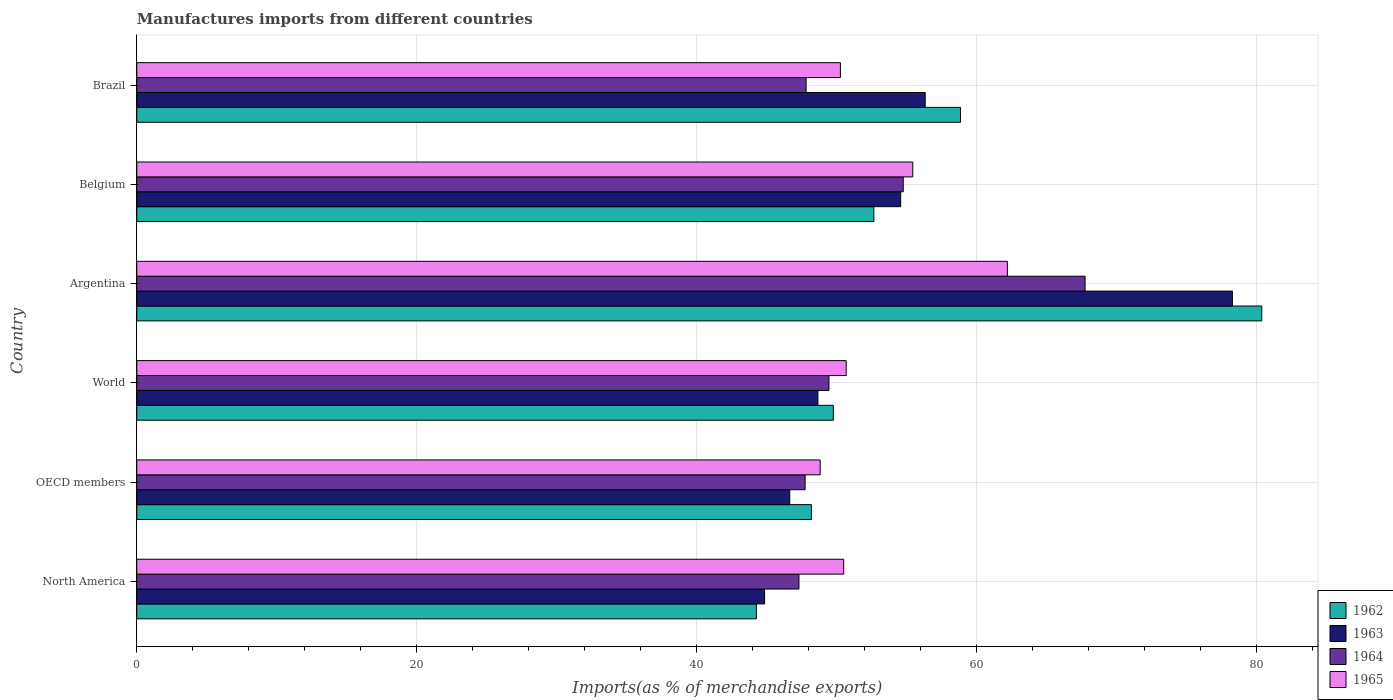How many different coloured bars are there?
Ensure brevity in your answer.  4. How many groups of bars are there?
Give a very brief answer. 6. How many bars are there on the 4th tick from the top?
Your answer should be compact. 4. In how many cases, is the number of bars for a given country not equal to the number of legend labels?
Make the answer very short. 0. What is the percentage of imports to different countries in 1965 in OECD members?
Your response must be concise. 48.82. Across all countries, what is the maximum percentage of imports to different countries in 1962?
Offer a very short reply. 80.37. Across all countries, what is the minimum percentage of imports to different countries in 1965?
Offer a very short reply. 48.82. In which country was the percentage of imports to different countries in 1962 maximum?
Ensure brevity in your answer.  Argentina. In which country was the percentage of imports to different countries in 1963 minimum?
Your answer should be very brief. North America. What is the total percentage of imports to different countries in 1964 in the graph?
Offer a terse response. 314.81. What is the difference between the percentage of imports to different countries in 1962 in Belgium and that in OECD members?
Your answer should be compact. 4.46. What is the difference between the percentage of imports to different countries in 1962 in World and the percentage of imports to different countries in 1965 in North America?
Keep it short and to the point. -0.74. What is the average percentage of imports to different countries in 1965 per country?
Your answer should be very brief. 52.98. What is the difference between the percentage of imports to different countries in 1964 and percentage of imports to different countries in 1965 in Argentina?
Your response must be concise. 5.55. What is the ratio of the percentage of imports to different countries in 1965 in OECD members to that in World?
Keep it short and to the point. 0.96. Is the difference between the percentage of imports to different countries in 1964 in Brazil and World greater than the difference between the percentage of imports to different countries in 1965 in Brazil and World?
Offer a terse response. No. What is the difference between the highest and the second highest percentage of imports to different countries in 1964?
Provide a succinct answer. 12.99. What is the difference between the highest and the lowest percentage of imports to different countries in 1962?
Offer a terse response. 36.1. Is it the case that in every country, the sum of the percentage of imports to different countries in 1962 and percentage of imports to different countries in 1965 is greater than the sum of percentage of imports to different countries in 1963 and percentage of imports to different countries in 1964?
Make the answer very short. No. What does the 2nd bar from the bottom in OECD members represents?
Your response must be concise. 1963. How many bars are there?
Provide a short and direct response. 24. How many countries are there in the graph?
Your answer should be compact. 6. Does the graph contain any zero values?
Keep it short and to the point. No. How many legend labels are there?
Give a very brief answer. 4. What is the title of the graph?
Your response must be concise. Manufactures imports from different countries. What is the label or title of the X-axis?
Give a very brief answer. Imports(as % of merchandise exports). What is the Imports(as % of merchandise exports) of 1962 in North America?
Offer a terse response. 44.26. What is the Imports(as % of merchandise exports) of 1963 in North America?
Your answer should be very brief. 44.85. What is the Imports(as % of merchandise exports) of 1964 in North America?
Your answer should be very brief. 47.3. What is the Imports(as % of merchandise exports) in 1965 in North America?
Make the answer very short. 50.5. What is the Imports(as % of merchandise exports) of 1962 in OECD members?
Your answer should be very brief. 48.19. What is the Imports(as % of merchandise exports) in 1963 in OECD members?
Provide a short and direct response. 46.65. What is the Imports(as % of merchandise exports) of 1964 in OECD members?
Make the answer very short. 47.75. What is the Imports(as % of merchandise exports) in 1965 in OECD members?
Offer a very short reply. 48.82. What is the Imports(as % of merchandise exports) in 1962 in World?
Offer a terse response. 49.76. What is the Imports(as % of merchandise exports) of 1963 in World?
Make the answer very short. 48.66. What is the Imports(as % of merchandise exports) in 1964 in World?
Your answer should be very brief. 49.45. What is the Imports(as % of merchandise exports) in 1965 in World?
Ensure brevity in your answer.  50.68. What is the Imports(as % of merchandise exports) of 1962 in Argentina?
Your response must be concise. 80.37. What is the Imports(as % of merchandise exports) in 1963 in Argentina?
Provide a succinct answer. 78.27. What is the Imports(as % of merchandise exports) in 1964 in Argentina?
Offer a very short reply. 67.75. What is the Imports(as % of merchandise exports) of 1965 in Argentina?
Your response must be concise. 62.19. What is the Imports(as % of merchandise exports) of 1962 in Belgium?
Ensure brevity in your answer.  52.65. What is the Imports(as % of merchandise exports) of 1963 in Belgium?
Make the answer very short. 54.57. What is the Imports(as % of merchandise exports) of 1964 in Belgium?
Your response must be concise. 54.75. What is the Imports(as % of merchandise exports) of 1965 in Belgium?
Provide a short and direct response. 55.44. What is the Imports(as % of merchandise exports) of 1962 in Brazil?
Keep it short and to the point. 58.85. What is the Imports(as % of merchandise exports) in 1963 in Brazil?
Your response must be concise. 56.32. What is the Imports(as % of merchandise exports) of 1964 in Brazil?
Make the answer very short. 47.82. What is the Imports(as % of merchandise exports) in 1965 in Brazil?
Ensure brevity in your answer.  50.27. Across all countries, what is the maximum Imports(as % of merchandise exports) of 1962?
Your answer should be compact. 80.37. Across all countries, what is the maximum Imports(as % of merchandise exports) in 1963?
Provide a short and direct response. 78.27. Across all countries, what is the maximum Imports(as % of merchandise exports) in 1964?
Your answer should be compact. 67.75. Across all countries, what is the maximum Imports(as % of merchandise exports) of 1965?
Your answer should be compact. 62.19. Across all countries, what is the minimum Imports(as % of merchandise exports) of 1962?
Your answer should be compact. 44.26. Across all countries, what is the minimum Imports(as % of merchandise exports) of 1963?
Provide a short and direct response. 44.85. Across all countries, what is the minimum Imports(as % of merchandise exports) in 1964?
Give a very brief answer. 47.3. Across all countries, what is the minimum Imports(as % of merchandise exports) in 1965?
Your answer should be very brief. 48.82. What is the total Imports(as % of merchandise exports) in 1962 in the graph?
Your answer should be very brief. 334.08. What is the total Imports(as % of merchandise exports) in 1963 in the graph?
Offer a terse response. 329.32. What is the total Imports(as % of merchandise exports) in 1964 in the graph?
Keep it short and to the point. 314.81. What is the total Imports(as % of merchandise exports) of 1965 in the graph?
Ensure brevity in your answer.  317.9. What is the difference between the Imports(as % of merchandise exports) of 1962 in North America and that in OECD members?
Ensure brevity in your answer.  -3.93. What is the difference between the Imports(as % of merchandise exports) of 1963 in North America and that in OECD members?
Ensure brevity in your answer.  -1.8. What is the difference between the Imports(as % of merchandise exports) of 1964 in North America and that in OECD members?
Your answer should be compact. -0.44. What is the difference between the Imports(as % of merchandise exports) of 1965 in North America and that in OECD members?
Make the answer very short. 1.68. What is the difference between the Imports(as % of merchandise exports) of 1962 in North America and that in World?
Provide a short and direct response. -5.5. What is the difference between the Imports(as % of merchandise exports) of 1963 in North America and that in World?
Give a very brief answer. -3.81. What is the difference between the Imports(as % of merchandise exports) of 1964 in North America and that in World?
Provide a succinct answer. -2.14. What is the difference between the Imports(as % of merchandise exports) of 1965 in North America and that in World?
Offer a very short reply. -0.18. What is the difference between the Imports(as % of merchandise exports) of 1962 in North America and that in Argentina?
Provide a short and direct response. -36.1. What is the difference between the Imports(as % of merchandise exports) in 1963 in North America and that in Argentina?
Ensure brevity in your answer.  -33.42. What is the difference between the Imports(as % of merchandise exports) of 1964 in North America and that in Argentina?
Ensure brevity in your answer.  -20.44. What is the difference between the Imports(as % of merchandise exports) of 1965 in North America and that in Argentina?
Offer a terse response. -11.69. What is the difference between the Imports(as % of merchandise exports) in 1962 in North America and that in Belgium?
Give a very brief answer. -8.39. What is the difference between the Imports(as % of merchandise exports) in 1963 in North America and that in Belgium?
Your answer should be very brief. -9.72. What is the difference between the Imports(as % of merchandise exports) of 1964 in North America and that in Belgium?
Provide a succinct answer. -7.45. What is the difference between the Imports(as % of merchandise exports) of 1965 in North America and that in Belgium?
Offer a very short reply. -4.93. What is the difference between the Imports(as % of merchandise exports) in 1962 in North America and that in Brazil?
Provide a short and direct response. -14.58. What is the difference between the Imports(as % of merchandise exports) of 1963 in North America and that in Brazil?
Ensure brevity in your answer.  -11.47. What is the difference between the Imports(as % of merchandise exports) in 1964 in North America and that in Brazil?
Offer a very short reply. -0.51. What is the difference between the Imports(as % of merchandise exports) in 1965 in North America and that in Brazil?
Your answer should be very brief. 0.24. What is the difference between the Imports(as % of merchandise exports) of 1962 in OECD members and that in World?
Provide a succinct answer. -1.57. What is the difference between the Imports(as % of merchandise exports) of 1963 in OECD members and that in World?
Offer a very short reply. -2.01. What is the difference between the Imports(as % of merchandise exports) in 1964 in OECD members and that in World?
Offer a terse response. -1.7. What is the difference between the Imports(as % of merchandise exports) of 1965 in OECD members and that in World?
Make the answer very short. -1.86. What is the difference between the Imports(as % of merchandise exports) of 1962 in OECD members and that in Argentina?
Ensure brevity in your answer.  -32.17. What is the difference between the Imports(as % of merchandise exports) in 1963 in OECD members and that in Argentina?
Your response must be concise. -31.62. What is the difference between the Imports(as % of merchandise exports) of 1964 in OECD members and that in Argentina?
Provide a short and direct response. -20. What is the difference between the Imports(as % of merchandise exports) of 1965 in OECD members and that in Argentina?
Keep it short and to the point. -13.38. What is the difference between the Imports(as % of merchandise exports) in 1962 in OECD members and that in Belgium?
Provide a short and direct response. -4.46. What is the difference between the Imports(as % of merchandise exports) of 1963 in OECD members and that in Belgium?
Offer a very short reply. -7.93. What is the difference between the Imports(as % of merchandise exports) of 1964 in OECD members and that in Belgium?
Provide a succinct answer. -7.01. What is the difference between the Imports(as % of merchandise exports) in 1965 in OECD members and that in Belgium?
Make the answer very short. -6.62. What is the difference between the Imports(as % of merchandise exports) of 1962 in OECD members and that in Brazil?
Your answer should be compact. -10.66. What is the difference between the Imports(as % of merchandise exports) of 1963 in OECD members and that in Brazil?
Offer a terse response. -9.68. What is the difference between the Imports(as % of merchandise exports) of 1964 in OECD members and that in Brazil?
Provide a succinct answer. -0.07. What is the difference between the Imports(as % of merchandise exports) in 1965 in OECD members and that in Brazil?
Give a very brief answer. -1.45. What is the difference between the Imports(as % of merchandise exports) in 1962 in World and that in Argentina?
Provide a short and direct response. -30.61. What is the difference between the Imports(as % of merchandise exports) of 1963 in World and that in Argentina?
Provide a short and direct response. -29.61. What is the difference between the Imports(as % of merchandise exports) in 1964 in World and that in Argentina?
Your response must be concise. -18.3. What is the difference between the Imports(as % of merchandise exports) in 1965 in World and that in Argentina?
Provide a succinct answer. -11.52. What is the difference between the Imports(as % of merchandise exports) of 1962 in World and that in Belgium?
Offer a terse response. -2.89. What is the difference between the Imports(as % of merchandise exports) of 1963 in World and that in Belgium?
Your answer should be compact. -5.91. What is the difference between the Imports(as % of merchandise exports) of 1964 in World and that in Belgium?
Keep it short and to the point. -5.31. What is the difference between the Imports(as % of merchandise exports) in 1965 in World and that in Belgium?
Offer a terse response. -4.76. What is the difference between the Imports(as % of merchandise exports) of 1962 in World and that in Brazil?
Your answer should be compact. -9.09. What is the difference between the Imports(as % of merchandise exports) of 1963 in World and that in Brazil?
Your answer should be compact. -7.66. What is the difference between the Imports(as % of merchandise exports) in 1964 in World and that in Brazil?
Make the answer very short. 1.63. What is the difference between the Imports(as % of merchandise exports) of 1965 in World and that in Brazil?
Make the answer very short. 0.41. What is the difference between the Imports(as % of merchandise exports) of 1962 in Argentina and that in Belgium?
Your answer should be compact. 27.71. What is the difference between the Imports(as % of merchandise exports) in 1963 in Argentina and that in Belgium?
Make the answer very short. 23.7. What is the difference between the Imports(as % of merchandise exports) in 1964 in Argentina and that in Belgium?
Your answer should be very brief. 12.99. What is the difference between the Imports(as % of merchandise exports) in 1965 in Argentina and that in Belgium?
Offer a very short reply. 6.76. What is the difference between the Imports(as % of merchandise exports) in 1962 in Argentina and that in Brazil?
Keep it short and to the point. 21.52. What is the difference between the Imports(as % of merchandise exports) in 1963 in Argentina and that in Brazil?
Offer a very short reply. 21.95. What is the difference between the Imports(as % of merchandise exports) in 1964 in Argentina and that in Brazil?
Your answer should be very brief. 19.93. What is the difference between the Imports(as % of merchandise exports) in 1965 in Argentina and that in Brazil?
Keep it short and to the point. 11.93. What is the difference between the Imports(as % of merchandise exports) in 1962 in Belgium and that in Brazil?
Give a very brief answer. -6.19. What is the difference between the Imports(as % of merchandise exports) in 1963 in Belgium and that in Brazil?
Give a very brief answer. -1.75. What is the difference between the Imports(as % of merchandise exports) in 1964 in Belgium and that in Brazil?
Your answer should be compact. 6.94. What is the difference between the Imports(as % of merchandise exports) of 1965 in Belgium and that in Brazil?
Offer a very short reply. 5.17. What is the difference between the Imports(as % of merchandise exports) of 1962 in North America and the Imports(as % of merchandise exports) of 1963 in OECD members?
Ensure brevity in your answer.  -2.38. What is the difference between the Imports(as % of merchandise exports) in 1962 in North America and the Imports(as % of merchandise exports) in 1964 in OECD members?
Offer a terse response. -3.48. What is the difference between the Imports(as % of merchandise exports) in 1962 in North America and the Imports(as % of merchandise exports) in 1965 in OECD members?
Provide a succinct answer. -4.56. What is the difference between the Imports(as % of merchandise exports) in 1963 in North America and the Imports(as % of merchandise exports) in 1964 in OECD members?
Provide a succinct answer. -2.89. What is the difference between the Imports(as % of merchandise exports) in 1963 in North America and the Imports(as % of merchandise exports) in 1965 in OECD members?
Your answer should be compact. -3.97. What is the difference between the Imports(as % of merchandise exports) of 1964 in North America and the Imports(as % of merchandise exports) of 1965 in OECD members?
Offer a terse response. -1.52. What is the difference between the Imports(as % of merchandise exports) in 1962 in North America and the Imports(as % of merchandise exports) in 1963 in World?
Give a very brief answer. -4.4. What is the difference between the Imports(as % of merchandise exports) in 1962 in North America and the Imports(as % of merchandise exports) in 1964 in World?
Ensure brevity in your answer.  -5.19. What is the difference between the Imports(as % of merchandise exports) in 1962 in North America and the Imports(as % of merchandise exports) in 1965 in World?
Offer a terse response. -6.42. What is the difference between the Imports(as % of merchandise exports) in 1963 in North America and the Imports(as % of merchandise exports) in 1964 in World?
Offer a very short reply. -4.6. What is the difference between the Imports(as % of merchandise exports) in 1963 in North America and the Imports(as % of merchandise exports) in 1965 in World?
Offer a terse response. -5.83. What is the difference between the Imports(as % of merchandise exports) of 1964 in North America and the Imports(as % of merchandise exports) of 1965 in World?
Keep it short and to the point. -3.37. What is the difference between the Imports(as % of merchandise exports) of 1962 in North America and the Imports(as % of merchandise exports) of 1963 in Argentina?
Offer a very short reply. -34.01. What is the difference between the Imports(as % of merchandise exports) in 1962 in North America and the Imports(as % of merchandise exports) in 1964 in Argentina?
Provide a succinct answer. -23.48. What is the difference between the Imports(as % of merchandise exports) of 1962 in North America and the Imports(as % of merchandise exports) of 1965 in Argentina?
Keep it short and to the point. -17.93. What is the difference between the Imports(as % of merchandise exports) of 1963 in North America and the Imports(as % of merchandise exports) of 1964 in Argentina?
Offer a very short reply. -22.89. What is the difference between the Imports(as % of merchandise exports) in 1963 in North America and the Imports(as % of merchandise exports) in 1965 in Argentina?
Offer a very short reply. -17.34. What is the difference between the Imports(as % of merchandise exports) in 1964 in North America and the Imports(as % of merchandise exports) in 1965 in Argentina?
Your answer should be very brief. -14.89. What is the difference between the Imports(as % of merchandise exports) in 1962 in North America and the Imports(as % of merchandise exports) in 1963 in Belgium?
Provide a succinct answer. -10.31. What is the difference between the Imports(as % of merchandise exports) in 1962 in North America and the Imports(as % of merchandise exports) in 1964 in Belgium?
Offer a terse response. -10.49. What is the difference between the Imports(as % of merchandise exports) of 1962 in North America and the Imports(as % of merchandise exports) of 1965 in Belgium?
Provide a short and direct response. -11.17. What is the difference between the Imports(as % of merchandise exports) in 1963 in North America and the Imports(as % of merchandise exports) in 1964 in Belgium?
Give a very brief answer. -9.9. What is the difference between the Imports(as % of merchandise exports) of 1963 in North America and the Imports(as % of merchandise exports) of 1965 in Belgium?
Your answer should be very brief. -10.58. What is the difference between the Imports(as % of merchandise exports) in 1964 in North America and the Imports(as % of merchandise exports) in 1965 in Belgium?
Ensure brevity in your answer.  -8.13. What is the difference between the Imports(as % of merchandise exports) in 1962 in North America and the Imports(as % of merchandise exports) in 1963 in Brazil?
Make the answer very short. -12.06. What is the difference between the Imports(as % of merchandise exports) in 1962 in North America and the Imports(as % of merchandise exports) in 1964 in Brazil?
Your answer should be compact. -3.55. What is the difference between the Imports(as % of merchandise exports) of 1962 in North America and the Imports(as % of merchandise exports) of 1965 in Brazil?
Your answer should be compact. -6. What is the difference between the Imports(as % of merchandise exports) in 1963 in North America and the Imports(as % of merchandise exports) in 1964 in Brazil?
Offer a very short reply. -2.96. What is the difference between the Imports(as % of merchandise exports) in 1963 in North America and the Imports(as % of merchandise exports) in 1965 in Brazil?
Give a very brief answer. -5.42. What is the difference between the Imports(as % of merchandise exports) of 1964 in North America and the Imports(as % of merchandise exports) of 1965 in Brazil?
Give a very brief answer. -2.96. What is the difference between the Imports(as % of merchandise exports) of 1962 in OECD members and the Imports(as % of merchandise exports) of 1963 in World?
Ensure brevity in your answer.  -0.47. What is the difference between the Imports(as % of merchandise exports) of 1962 in OECD members and the Imports(as % of merchandise exports) of 1964 in World?
Your response must be concise. -1.26. What is the difference between the Imports(as % of merchandise exports) in 1962 in OECD members and the Imports(as % of merchandise exports) in 1965 in World?
Ensure brevity in your answer.  -2.49. What is the difference between the Imports(as % of merchandise exports) in 1963 in OECD members and the Imports(as % of merchandise exports) in 1964 in World?
Your response must be concise. -2.8. What is the difference between the Imports(as % of merchandise exports) of 1963 in OECD members and the Imports(as % of merchandise exports) of 1965 in World?
Your answer should be very brief. -4.03. What is the difference between the Imports(as % of merchandise exports) in 1964 in OECD members and the Imports(as % of merchandise exports) in 1965 in World?
Offer a terse response. -2.93. What is the difference between the Imports(as % of merchandise exports) of 1962 in OECD members and the Imports(as % of merchandise exports) of 1963 in Argentina?
Make the answer very short. -30.08. What is the difference between the Imports(as % of merchandise exports) of 1962 in OECD members and the Imports(as % of merchandise exports) of 1964 in Argentina?
Your answer should be very brief. -19.55. What is the difference between the Imports(as % of merchandise exports) in 1962 in OECD members and the Imports(as % of merchandise exports) in 1965 in Argentina?
Ensure brevity in your answer.  -14. What is the difference between the Imports(as % of merchandise exports) of 1963 in OECD members and the Imports(as % of merchandise exports) of 1964 in Argentina?
Ensure brevity in your answer.  -21.1. What is the difference between the Imports(as % of merchandise exports) in 1963 in OECD members and the Imports(as % of merchandise exports) in 1965 in Argentina?
Your answer should be compact. -15.55. What is the difference between the Imports(as % of merchandise exports) of 1964 in OECD members and the Imports(as % of merchandise exports) of 1965 in Argentina?
Ensure brevity in your answer.  -14.45. What is the difference between the Imports(as % of merchandise exports) of 1962 in OECD members and the Imports(as % of merchandise exports) of 1963 in Belgium?
Provide a succinct answer. -6.38. What is the difference between the Imports(as % of merchandise exports) in 1962 in OECD members and the Imports(as % of merchandise exports) in 1964 in Belgium?
Provide a succinct answer. -6.56. What is the difference between the Imports(as % of merchandise exports) of 1962 in OECD members and the Imports(as % of merchandise exports) of 1965 in Belgium?
Make the answer very short. -7.24. What is the difference between the Imports(as % of merchandise exports) of 1963 in OECD members and the Imports(as % of merchandise exports) of 1964 in Belgium?
Provide a succinct answer. -8.11. What is the difference between the Imports(as % of merchandise exports) of 1963 in OECD members and the Imports(as % of merchandise exports) of 1965 in Belgium?
Keep it short and to the point. -8.79. What is the difference between the Imports(as % of merchandise exports) in 1964 in OECD members and the Imports(as % of merchandise exports) in 1965 in Belgium?
Provide a succinct answer. -7.69. What is the difference between the Imports(as % of merchandise exports) in 1962 in OECD members and the Imports(as % of merchandise exports) in 1963 in Brazil?
Make the answer very short. -8.13. What is the difference between the Imports(as % of merchandise exports) in 1962 in OECD members and the Imports(as % of merchandise exports) in 1964 in Brazil?
Your answer should be compact. 0.38. What is the difference between the Imports(as % of merchandise exports) in 1962 in OECD members and the Imports(as % of merchandise exports) in 1965 in Brazil?
Offer a terse response. -2.08. What is the difference between the Imports(as % of merchandise exports) of 1963 in OECD members and the Imports(as % of merchandise exports) of 1964 in Brazil?
Your response must be concise. -1.17. What is the difference between the Imports(as % of merchandise exports) in 1963 in OECD members and the Imports(as % of merchandise exports) in 1965 in Brazil?
Your answer should be compact. -3.62. What is the difference between the Imports(as % of merchandise exports) of 1964 in OECD members and the Imports(as % of merchandise exports) of 1965 in Brazil?
Your answer should be compact. -2.52. What is the difference between the Imports(as % of merchandise exports) of 1962 in World and the Imports(as % of merchandise exports) of 1963 in Argentina?
Give a very brief answer. -28.51. What is the difference between the Imports(as % of merchandise exports) in 1962 in World and the Imports(as % of merchandise exports) in 1964 in Argentina?
Provide a short and direct response. -17.98. What is the difference between the Imports(as % of merchandise exports) of 1962 in World and the Imports(as % of merchandise exports) of 1965 in Argentina?
Give a very brief answer. -12.43. What is the difference between the Imports(as % of merchandise exports) in 1963 in World and the Imports(as % of merchandise exports) in 1964 in Argentina?
Give a very brief answer. -19.09. What is the difference between the Imports(as % of merchandise exports) in 1963 in World and the Imports(as % of merchandise exports) in 1965 in Argentina?
Ensure brevity in your answer.  -13.54. What is the difference between the Imports(as % of merchandise exports) in 1964 in World and the Imports(as % of merchandise exports) in 1965 in Argentina?
Provide a short and direct response. -12.75. What is the difference between the Imports(as % of merchandise exports) of 1962 in World and the Imports(as % of merchandise exports) of 1963 in Belgium?
Make the answer very short. -4.81. What is the difference between the Imports(as % of merchandise exports) of 1962 in World and the Imports(as % of merchandise exports) of 1964 in Belgium?
Give a very brief answer. -4.99. What is the difference between the Imports(as % of merchandise exports) in 1962 in World and the Imports(as % of merchandise exports) in 1965 in Belgium?
Offer a terse response. -5.67. What is the difference between the Imports(as % of merchandise exports) in 1963 in World and the Imports(as % of merchandise exports) in 1964 in Belgium?
Offer a terse response. -6.09. What is the difference between the Imports(as % of merchandise exports) in 1963 in World and the Imports(as % of merchandise exports) in 1965 in Belgium?
Your answer should be compact. -6.78. What is the difference between the Imports(as % of merchandise exports) in 1964 in World and the Imports(as % of merchandise exports) in 1965 in Belgium?
Your answer should be compact. -5.99. What is the difference between the Imports(as % of merchandise exports) in 1962 in World and the Imports(as % of merchandise exports) in 1963 in Brazil?
Provide a short and direct response. -6.56. What is the difference between the Imports(as % of merchandise exports) of 1962 in World and the Imports(as % of merchandise exports) of 1964 in Brazil?
Provide a short and direct response. 1.95. What is the difference between the Imports(as % of merchandise exports) in 1962 in World and the Imports(as % of merchandise exports) in 1965 in Brazil?
Offer a terse response. -0.51. What is the difference between the Imports(as % of merchandise exports) of 1963 in World and the Imports(as % of merchandise exports) of 1964 in Brazil?
Offer a very short reply. 0.84. What is the difference between the Imports(as % of merchandise exports) of 1963 in World and the Imports(as % of merchandise exports) of 1965 in Brazil?
Your answer should be very brief. -1.61. What is the difference between the Imports(as % of merchandise exports) in 1964 in World and the Imports(as % of merchandise exports) in 1965 in Brazil?
Keep it short and to the point. -0.82. What is the difference between the Imports(as % of merchandise exports) in 1962 in Argentina and the Imports(as % of merchandise exports) in 1963 in Belgium?
Give a very brief answer. 25.79. What is the difference between the Imports(as % of merchandise exports) of 1962 in Argentina and the Imports(as % of merchandise exports) of 1964 in Belgium?
Ensure brevity in your answer.  25.61. What is the difference between the Imports(as % of merchandise exports) in 1962 in Argentina and the Imports(as % of merchandise exports) in 1965 in Belgium?
Your response must be concise. 24.93. What is the difference between the Imports(as % of merchandise exports) of 1963 in Argentina and the Imports(as % of merchandise exports) of 1964 in Belgium?
Provide a short and direct response. 23.52. What is the difference between the Imports(as % of merchandise exports) in 1963 in Argentina and the Imports(as % of merchandise exports) in 1965 in Belgium?
Your response must be concise. 22.83. What is the difference between the Imports(as % of merchandise exports) of 1964 in Argentina and the Imports(as % of merchandise exports) of 1965 in Belgium?
Your answer should be compact. 12.31. What is the difference between the Imports(as % of merchandise exports) in 1962 in Argentina and the Imports(as % of merchandise exports) in 1963 in Brazil?
Provide a succinct answer. 24.04. What is the difference between the Imports(as % of merchandise exports) of 1962 in Argentina and the Imports(as % of merchandise exports) of 1964 in Brazil?
Offer a very short reply. 32.55. What is the difference between the Imports(as % of merchandise exports) of 1962 in Argentina and the Imports(as % of merchandise exports) of 1965 in Brazil?
Offer a terse response. 30.1. What is the difference between the Imports(as % of merchandise exports) of 1963 in Argentina and the Imports(as % of merchandise exports) of 1964 in Brazil?
Give a very brief answer. 30.45. What is the difference between the Imports(as % of merchandise exports) in 1963 in Argentina and the Imports(as % of merchandise exports) in 1965 in Brazil?
Provide a short and direct response. 28. What is the difference between the Imports(as % of merchandise exports) of 1964 in Argentina and the Imports(as % of merchandise exports) of 1965 in Brazil?
Your answer should be compact. 17.48. What is the difference between the Imports(as % of merchandise exports) in 1962 in Belgium and the Imports(as % of merchandise exports) in 1963 in Brazil?
Your response must be concise. -3.67. What is the difference between the Imports(as % of merchandise exports) of 1962 in Belgium and the Imports(as % of merchandise exports) of 1964 in Brazil?
Ensure brevity in your answer.  4.84. What is the difference between the Imports(as % of merchandise exports) of 1962 in Belgium and the Imports(as % of merchandise exports) of 1965 in Brazil?
Provide a succinct answer. 2.39. What is the difference between the Imports(as % of merchandise exports) of 1963 in Belgium and the Imports(as % of merchandise exports) of 1964 in Brazil?
Make the answer very short. 6.76. What is the difference between the Imports(as % of merchandise exports) in 1963 in Belgium and the Imports(as % of merchandise exports) in 1965 in Brazil?
Offer a very short reply. 4.31. What is the difference between the Imports(as % of merchandise exports) of 1964 in Belgium and the Imports(as % of merchandise exports) of 1965 in Brazil?
Your response must be concise. 4.49. What is the average Imports(as % of merchandise exports) of 1962 per country?
Ensure brevity in your answer.  55.68. What is the average Imports(as % of merchandise exports) of 1963 per country?
Your answer should be compact. 54.89. What is the average Imports(as % of merchandise exports) of 1964 per country?
Offer a very short reply. 52.47. What is the average Imports(as % of merchandise exports) in 1965 per country?
Your response must be concise. 52.98. What is the difference between the Imports(as % of merchandise exports) of 1962 and Imports(as % of merchandise exports) of 1963 in North America?
Ensure brevity in your answer.  -0.59. What is the difference between the Imports(as % of merchandise exports) of 1962 and Imports(as % of merchandise exports) of 1964 in North America?
Provide a succinct answer. -3.04. What is the difference between the Imports(as % of merchandise exports) of 1962 and Imports(as % of merchandise exports) of 1965 in North America?
Give a very brief answer. -6.24. What is the difference between the Imports(as % of merchandise exports) in 1963 and Imports(as % of merchandise exports) in 1964 in North America?
Your answer should be compact. -2.45. What is the difference between the Imports(as % of merchandise exports) in 1963 and Imports(as % of merchandise exports) in 1965 in North America?
Provide a short and direct response. -5.65. What is the difference between the Imports(as % of merchandise exports) in 1964 and Imports(as % of merchandise exports) in 1965 in North America?
Provide a succinct answer. -3.2. What is the difference between the Imports(as % of merchandise exports) in 1962 and Imports(as % of merchandise exports) in 1963 in OECD members?
Offer a very short reply. 1.55. What is the difference between the Imports(as % of merchandise exports) of 1962 and Imports(as % of merchandise exports) of 1964 in OECD members?
Provide a short and direct response. 0.45. What is the difference between the Imports(as % of merchandise exports) of 1962 and Imports(as % of merchandise exports) of 1965 in OECD members?
Your answer should be very brief. -0.63. What is the difference between the Imports(as % of merchandise exports) of 1963 and Imports(as % of merchandise exports) of 1964 in OECD members?
Offer a very short reply. -1.1. What is the difference between the Imports(as % of merchandise exports) in 1963 and Imports(as % of merchandise exports) in 1965 in OECD members?
Keep it short and to the point. -2.17. What is the difference between the Imports(as % of merchandise exports) in 1964 and Imports(as % of merchandise exports) in 1965 in OECD members?
Ensure brevity in your answer.  -1.07. What is the difference between the Imports(as % of merchandise exports) in 1962 and Imports(as % of merchandise exports) in 1963 in World?
Provide a short and direct response. 1.1. What is the difference between the Imports(as % of merchandise exports) of 1962 and Imports(as % of merchandise exports) of 1964 in World?
Keep it short and to the point. 0.31. What is the difference between the Imports(as % of merchandise exports) of 1962 and Imports(as % of merchandise exports) of 1965 in World?
Your answer should be very brief. -0.92. What is the difference between the Imports(as % of merchandise exports) in 1963 and Imports(as % of merchandise exports) in 1964 in World?
Offer a terse response. -0.79. What is the difference between the Imports(as % of merchandise exports) of 1963 and Imports(as % of merchandise exports) of 1965 in World?
Keep it short and to the point. -2.02. What is the difference between the Imports(as % of merchandise exports) of 1964 and Imports(as % of merchandise exports) of 1965 in World?
Keep it short and to the point. -1.23. What is the difference between the Imports(as % of merchandise exports) in 1962 and Imports(as % of merchandise exports) in 1963 in Argentina?
Provide a succinct answer. 2.1. What is the difference between the Imports(as % of merchandise exports) of 1962 and Imports(as % of merchandise exports) of 1964 in Argentina?
Your response must be concise. 12.62. What is the difference between the Imports(as % of merchandise exports) in 1962 and Imports(as % of merchandise exports) in 1965 in Argentina?
Your answer should be very brief. 18.17. What is the difference between the Imports(as % of merchandise exports) in 1963 and Imports(as % of merchandise exports) in 1964 in Argentina?
Your answer should be very brief. 10.52. What is the difference between the Imports(as % of merchandise exports) in 1963 and Imports(as % of merchandise exports) in 1965 in Argentina?
Offer a very short reply. 16.08. What is the difference between the Imports(as % of merchandise exports) of 1964 and Imports(as % of merchandise exports) of 1965 in Argentina?
Offer a very short reply. 5.55. What is the difference between the Imports(as % of merchandise exports) of 1962 and Imports(as % of merchandise exports) of 1963 in Belgium?
Make the answer very short. -1.92. What is the difference between the Imports(as % of merchandise exports) of 1962 and Imports(as % of merchandise exports) of 1964 in Belgium?
Give a very brief answer. -2.1. What is the difference between the Imports(as % of merchandise exports) of 1962 and Imports(as % of merchandise exports) of 1965 in Belgium?
Offer a terse response. -2.78. What is the difference between the Imports(as % of merchandise exports) in 1963 and Imports(as % of merchandise exports) in 1964 in Belgium?
Your answer should be compact. -0.18. What is the difference between the Imports(as % of merchandise exports) in 1963 and Imports(as % of merchandise exports) in 1965 in Belgium?
Offer a very short reply. -0.86. What is the difference between the Imports(as % of merchandise exports) in 1964 and Imports(as % of merchandise exports) in 1965 in Belgium?
Ensure brevity in your answer.  -0.68. What is the difference between the Imports(as % of merchandise exports) of 1962 and Imports(as % of merchandise exports) of 1963 in Brazil?
Your answer should be compact. 2.52. What is the difference between the Imports(as % of merchandise exports) in 1962 and Imports(as % of merchandise exports) in 1964 in Brazil?
Make the answer very short. 11.03. What is the difference between the Imports(as % of merchandise exports) of 1962 and Imports(as % of merchandise exports) of 1965 in Brazil?
Ensure brevity in your answer.  8.58. What is the difference between the Imports(as % of merchandise exports) of 1963 and Imports(as % of merchandise exports) of 1964 in Brazil?
Provide a short and direct response. 8.51. What is the difference between the Imports(as % of merchandise exports) in 1963 and Imports(as % of merchandise exports) in 1965 in Brazil?
Make the answer very short. 6.06. What is the difference between the Imports(as % of merchandise exports) in 1964 and Imports(as % of merchandise exports) in 1965 in Brazil?
Provide a short and direct response. -2.45. What is the ratio of the Imports(as % of merchandise exports) in 1962 in North America to that in OECD members?
Offer a very short reply. 0.92. What is the ratio of the Imports(as % of merchandise exports) in 1963 in North America to that in OECD members?
Give a very brief answer. 0.96. What is the ratio of the Imports(as % of merchandise exports) of 1965 in North America to that in OECD members?
Your answer should be compact. 1.03. What is the ratio of the Imports(as % of merchandise exports) of 1962 in North America to that in World?
Provide a succinct answer. 0.89. What is the ratio of the Imports(as % of merchandise exports) in 1963 in North America to that in World?
Ensure brevity in your answer.  0.92. What is the ratio of the Imports(as % of merchandise exports) in 1964 in North America to that in World?
Provide a short and direct response. 0.96. What is the ratio of the Imports(as % of merchandise exports) in 1962 in North America to that in Argentina?
Make the answer very short. 0.55. What is the ratio of the Imports(as % of merchandise exports) in 1963 in North America to that in Argentina?
Give a very brief answer. 0.57. What is the ratio of the Imports(as % of merchandise exports) in 1964 in North America to that in Argentina?
Offer a terse response. 0.7. What is the ratio of the Imports(as % of merchandise exports) in 1965 in North America to that in Argentina?
Offer a terse response. 0.81. What is the ratio of the Imports(as % of merchandise exports) in 1962 in North America to that in Belgium?
Your response must be concise. 0.84. What is the ratio of the Imports(as % of merchandise exports) in 1963 in North America to that in Belgium?
Offer a very short reply. 0.82. What is the ratio of the Imports(as % of merchandise exports) in 1964 in North America to that in Belgium?
Your answer should be compact. 0.86. What is the ratio of the Imports(as % of merchandise exports) of 1965 in North America to that in Belgium?
Offer a very short reply. 0.91. What is the ratio of the Imports(as % of merchandise exports) of 1962 in North America to that in Brazil?
Your answer should be very brief. 0.75. What is the ratio of the Imports(as % of merchandise exports) in 1963 in North America to that in Brazil?
Your response must be concise. 0.8. What is the ratio of the Imports(as % of merchandise exports) in 1964 in North America to that in Brazil?
Your response must be concise. 0.99. What is the ratio of the Imports(as % of merchandise exports) in 1962 in OECD members to that in World?
Your response must be concise. 0.97. What is the ratio of the Imports(as % of merchandise exports) of 1963 in OECD members to that in World?
Give a very brief answer. 0.96. What is the ratio of the Imports(as % of merchandise exports) of 1964 in OECD members to that in World?
Ensure brevity in your answer.  0.97. What is the ratio of the Imports(as % of merchandise exports) in 1965 in OECD members to that in World?
Offer a terse response. 0.96. What is the ratio of the Imports(as % of merchandise exports) of 1962 in OECD members to that in Argentina?
Offer a terse response. 0.6. What is the ratio of the Imports(as % of merchandise exports) of 1963 in OECD members to that in Argentina?
Ensure brevity in your answer.  0.6. What is the ratio of the Imports(as % of merchandise exports) of 1964 in OECD members to that in Argentina?
Keep it short and to the point. 0.7. What is the ratio of the Imports(as % of merchandise exports) in 1965 in OECD members to that in Argentina?
Your response must be concise. 0.78. What is the ratio of the Imports(as % of merchandise exports) in 1962 in OECD members to that in Belgium?
Ensure brevity in your answer.  0.92. What is the ratio of the Imports(as % of merchandise exports) of 1963 in OECD members to that in Belgium?
Provide a succinct answer. 0.85. What is the ratio of the Imports(as % of merchandise exports) in 1964 in OECD members to that in Belgium?
Provide a short and direct response. 0.87. What is the ratio of the Imports(as % of merchandise exports) of 1965 in OECD members to that in Belgium?
Your answer should be compact. 0.88. What is the ratio of the Imports(as % of merchandise exports) of 1962 in OECD members to that in Brazil?
Give a very brief answer. 0.82. What is the ratio of the Imports(as % of merchandise exports) of 1963 in OECD members to that in Brazil?
Offer a terse response. 0.83. What is the ratio of the Imports(as % of merchandise exports) in 1965 in OECD members to that in Brazil?
Keep it short and to the point. 0.97. What is the ratio of the Imports(as % of merchandise exports) of 1962 in World to that in Argentina?
Offer a terse response. 0.62. What is the ratio of the Imports(as % of merchandise exports) in 1963 in World to that in Argentina?
Your answer should be compact. 0.62. What is the ratio of the Imports(as % of merchandise exports) of 1964 in World to that in Argentina?
Provide a short and direct response. 0.73. What is the ratio of the Imports(as % of merchandise exports) in 1965 in World to that in Argentina?
Offer a very short reply. 0.81. What is the ratio of the Imports(as % of merchandise exports) of 1962 in World to that in Belgium?
Keep it short and to the point. 0.95. What is the ratio of the Imports(as % of merchandise exports) of 1963 in World to that in Belgium?
Your response must be concise. 0.89. What is the ratio of the Imports(as % of merchandise exports) of 1964 in World to that in Belgium?
Provide a succinct answer. 0.9. What is the ratio of the Imports(as % of merchandise exports) in 1965 in World to that in Belgium?
Provide a succinct answer. 0.91. What is the ratio of the Imports(as % of merchandise exports) in 1962 in World to that in Brazil?
Offer a terse response. 0.85. What is the ratio of the Imports(as % of merchandise exports) of 1963 in World to that in Brazil?
Ensure brevity in your answer.  0.86. What is the ratio of the Imports(as % of merchandise exports) of 1964 in World to that in Brazil?
Ensure brevity in your answer.  1.03. What is the ratio of the Imports(as % of merchandise exports) in 1965 in World to that in Brazil?
Your answer should be very brief. 1.01. What is the ratio of the Imports(as % of merchandise exports) of 1962 in Argentina to that in Belgium?
Your response must be concise. 1.53. What is the ratio of the Imports(as % of merchandise exports) of 1963 in Argentina to that in Belgium?
Your answer should be very brief. 1.43. What is the ratio of the Imports(as % of merchandise exports) of 1964 in Argentina to that in Belgium?
Make the answer very short. 1.24. What is the ratio of the Imports(as % of merchandise exports) of 1965 in Argentina to that in Belgium?
Your answer should be compact. 1.12. What is the ratio of the Imports(as % of merchandise exports) of 1962 in Argentina to that in Brazil?
Provide a succinct answer. 1.37. What is the ratio of the Imports(as % of merchandise exports) in 1963 in Argentina to that in Brazil?
Ensure brevity in your answer.  1.39. What is the ratio of the Imports(as % of merchandise exports) in 1964 in Argentina to that in Brazil?
Your answer should be compact. 1.42. What is the ratio of the Imports(as % of merchandise exports) of 1965 in Argentina to that in Brazil?
Ensure brevity in your answer.  1.24. What is the ratio of the Imports(as % of merchandise exports) in 1962 in Belgium to that in Brazil?
Your answer should be very brief. 0.89. What is the ratio of the Imports(as % of merchandise exports) of 1963 in Belgium to that in Brazil?
Your answer should be compact. 0.97. What is the ratio of the Imports(as % of merchandise exports) of 1964 in Belgium to that in Brazil?
Keep it short and to the point. 1.15. What is the ratio of the Imports(as % of merchandise exports) of 1965 in Belgium to that in Brazil?
Your response must be concise. 1.1. What is the difference between the highest and the second highest Imports(as % of merchandise exports) in 1962?
Ensure brevity in your answer.  21.52. What is the difference between the highest and the second highest Imports(as % of merchandise exports) of 1963?
Offer a terse response. 21.95. What is the difference between the highest and the second highest Imports(as % of merchandise exports) of 1964?
Your answer should be very brief. 12.99. What is the difference between the highest and the second highest Imports(as % of merchandise exports) of 1965?
Make the answer very short. 6.76. What is the difference between the highest and the lowest Imports(as % of merchandise exports) of 1962?
Your answer should be compact. 36.1. What is the difference between the highest and the lowest Imports(as % of merchandise exports) in 1963?
Provide a short and direct response. 33.42. What is the difference between the highest and the lowest Imports(as % of merchandise exports) in 1964?
Your answer should be compact. 20.44. What is the difference between the highest and the lowest Imports(as % of merchandise exports) in 1965?
Your answer should be compact. 13.38. 